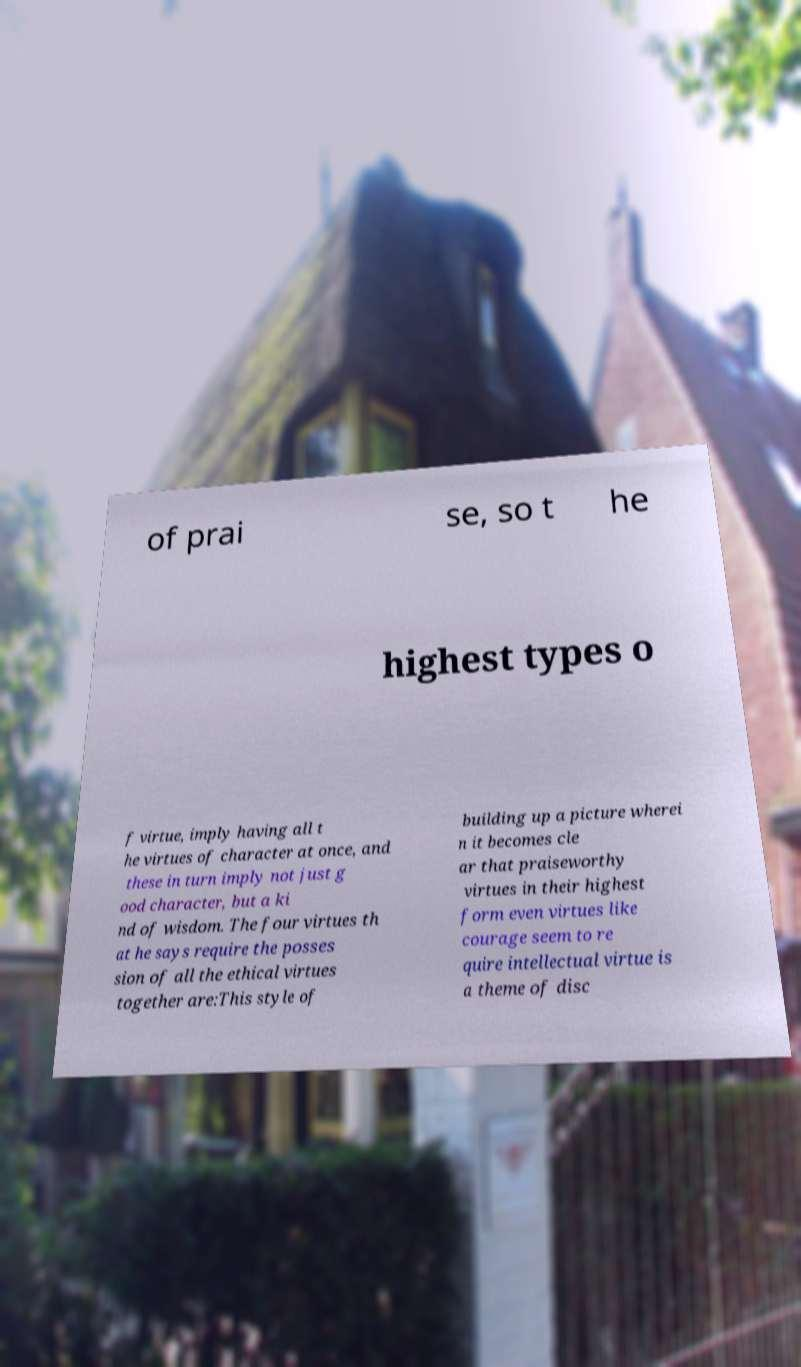For documentation purposes, I need the text within this image transcribed. Could you provide that? of prai se, so t he highest types o f virtue, imply having all t he virtues of character at once, and these in turn imply not just g ood character, but a ki nd of wisdom. The four virtues th at he says require the posses sion of all the ethical virtues together are:This style of building up a picture wherei n it becomes cle ar that praiseworthy virtues in their highest form even virtues like courage seem to re quire intellectual virtue is a theme of disc 